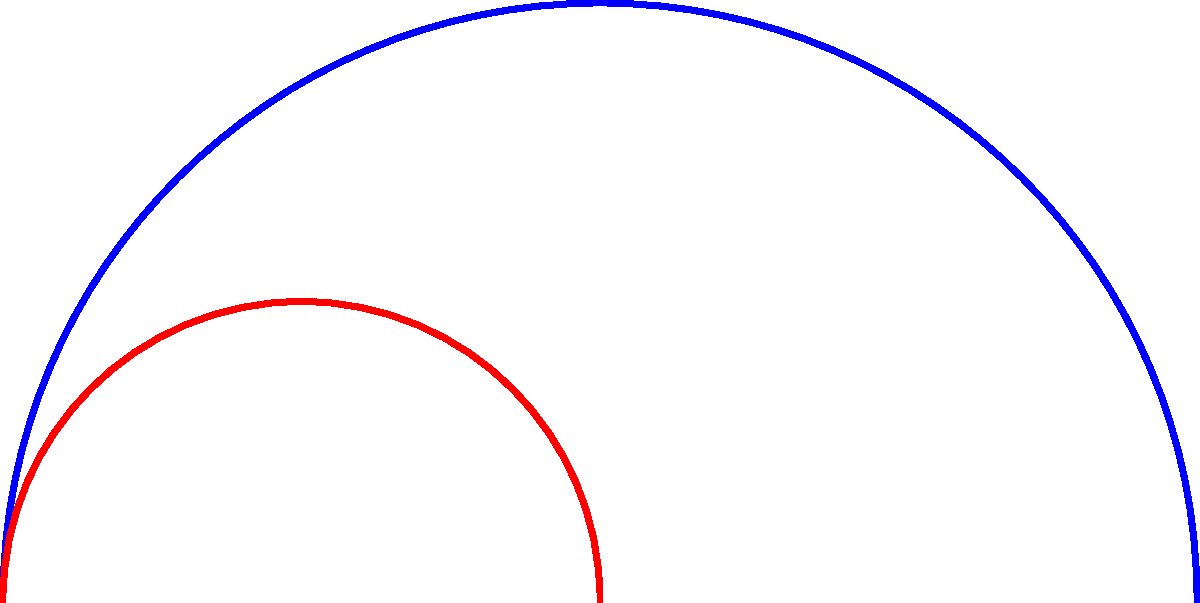In a historical building with curved corridors, a fire escape route is designed using non-Euclidean geometry. The original path ABC is scaled down by a factor of 0.5 to create a new path A'B'C'. How does the curvature of the scaled path A'B'C' compare to the original path ABC in non-Euclidean space? To understand how the curvature changes when scaling a curved path in non-Euclidean geometry, we need to follow these steps:

1. Recall that in non-Euclidean geometry, specifically in hyperbolic geometry, the curvature of space is constant and negative.

2. In Euclidean geometry, scaling a curve by a factor k would reduce its curvature by a factor of 1/k. However, this is not the case in non-Euclidean geometry.

3. In hyperbolic geometry, the curvature of a path is related to its deviation from a geodesic (the shortest path between two points in curved space).

4. When we scale a path in hyperbolic space, we're effectively moving it closer to or further from the origin of the hyperbolic plane.

5. As objects move away from the origin in hyperbolic space, they appear to shrink due to the nature of hyperbolic geometry. Conversely, as objects move closer to the origin, they appear to grow.

6. In our case, scaling the path down by 0.5 is equivalent to moving it closer to the origin in hyperbolic space.

7. As a result, the scaled path A'B'C' will actually have a greater curvature than the original path ABC, despite being smaller in size.

8. This is because the scaled path experiences a stronger effect of the hyperbolic space's curvature as it's closer to the origin.

Therefore, contrary to what we might expect in Euclidean geometry, the curvature of the scaled path A'B'C' is greater than the curvature of the original path ABC in non-Euclidean (hyperbolic) space.
Answer: Greater curvature 